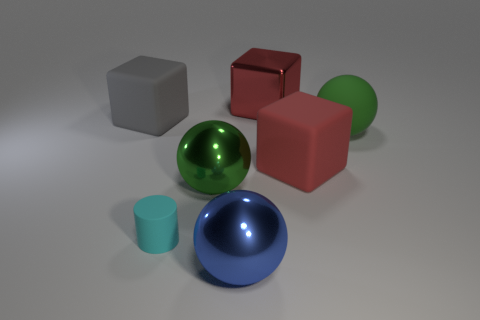Are there any other things that have the same size as the cyan rubber cylinder?
Provide a succinct answer. No. What number of big shiny things have the same color as the rubber sphere?
Make the answer very short. 1. What is the material of the large object that is the same color as the large matte sphere?
Your answer should be compact. Metal. Does the blue thing have the same material as the cylinder?
Your response must be concise. No. There is a big blue metal ball; are there any small cylinders in front of it?
Your response must be concise. No. What material is the object that is left of the cyan object to the left of the blue thing?
Give a very brief answer. Rubber. There is another metallic object that is the same shape as the gray thing; what size is it?
Offer a terse response. Large. Is the tiny matte thing the same color as the big matte ball?
Offer a terse response. No. There is a shiny object that is both in front of the large gray thing and behind the large blue metal sphere; what is its color?
Ensure brevity in your answer.  Green. Do the green sphere on the left side of the blue ball and the big green matte sphere have the same size?
Offer a terse response. Yes. 